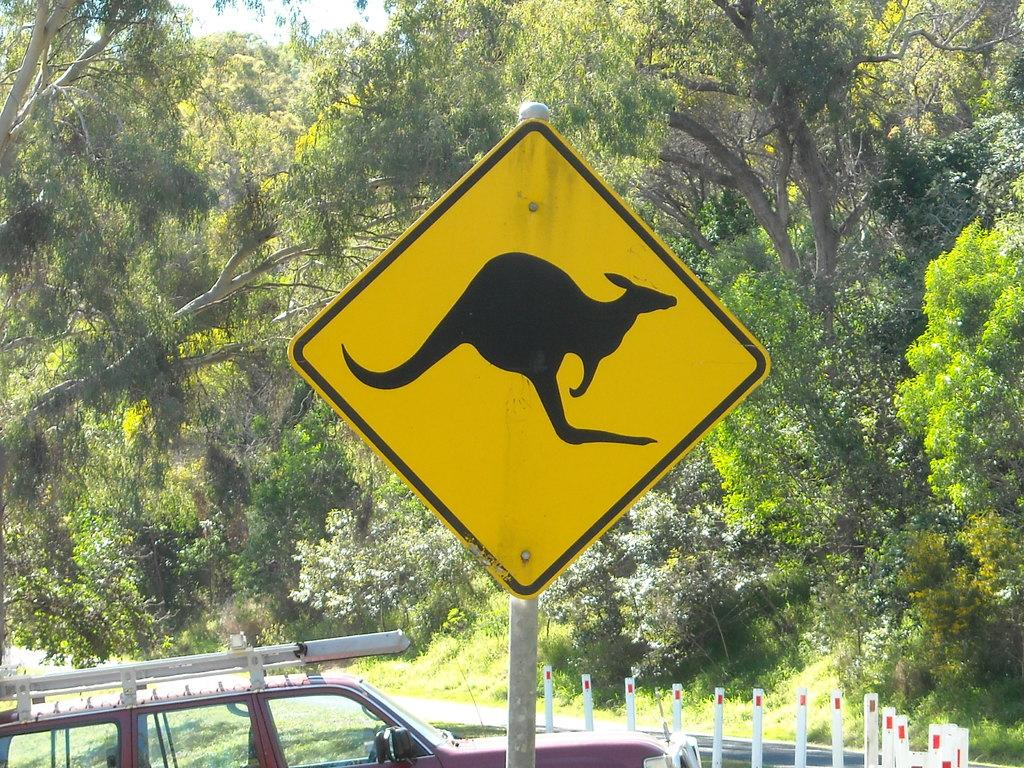What is the main object in the image? There is a sign board in the image. What is located behind the sign board? There is a car behind the sign board. What type of barrier can be seen in the image? There is a fence in the image. What type of path is visible in the image? There is a road in the image. What type of vegetation is present in the image? There is grass and trees in the image. What is visible at the top of the image? The sky is visible at the top of the image. What type of beef is being served to the visitor in the image? There is no beef or visitor present in the image. 